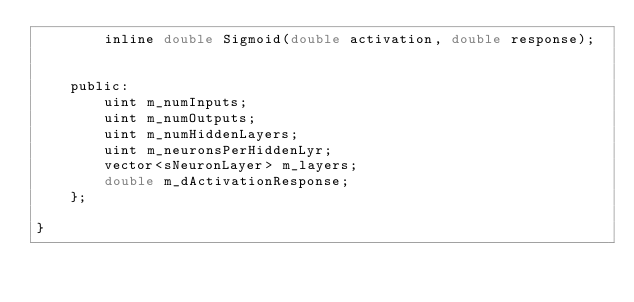<code> <loc_0><loc_0><loc_500><loc_500><_C_>		inline double Sigmoid(double activation, double response);


	public:
		uint m_numInputs;
		uint m_numOutputs;
		uint m_numHiddenLayers;
		uint m_neuronsPerHiddenLyr;
		vector<sNeuronLayer> m_layers;
		double m_dActivationResponse;
	};

}
</code> 